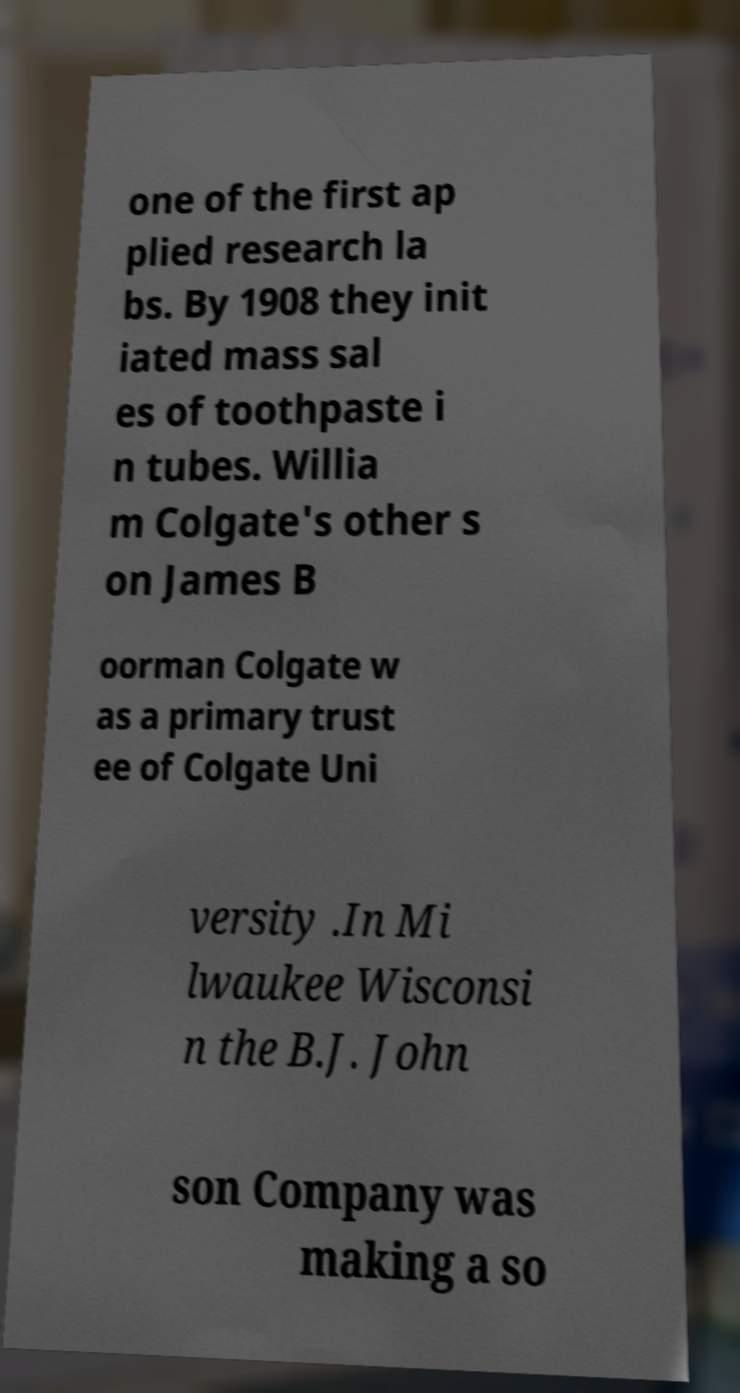I need the written content from this picture converted into text. Can you do that? one of the first ap plied research la bs. By 1908 they init iated mass sal es of toothpaste i n tubes. Willia m Colgate's other s on James B oorman Colgate w as a primary trust ee of Colgate Uni versity .In Mi lwaukee Wisconsi n the B.J. John son Company was making a so 